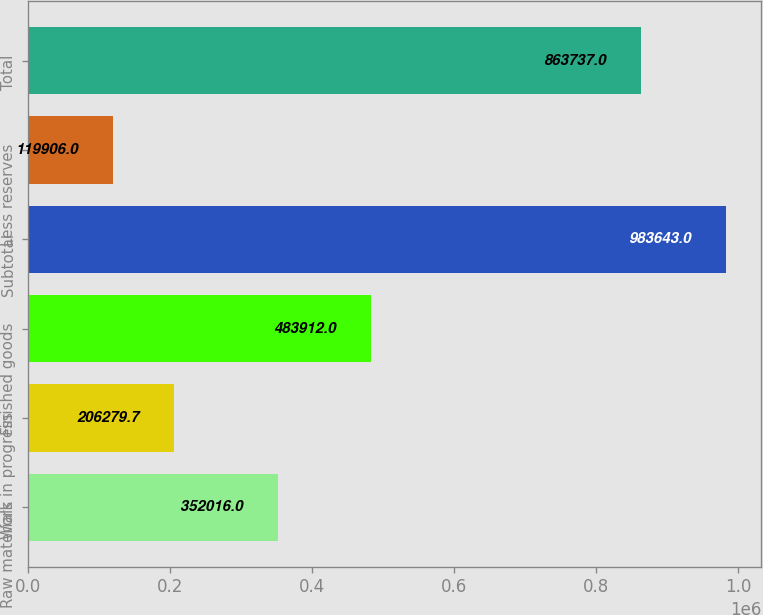<chart> <loc_0><loc_0><loc_500><loc_500><bar_chart><fcel>Raw materials<fcel>Work in progress<fcel>Finished goods<fcel>Subtotal<fcel>Less reserves<fcel>Total<nl><fcel>352016<fcel>206280<fcel>483912<fcel>983643<fcel>119906<fcel>863737<nl></chart> 